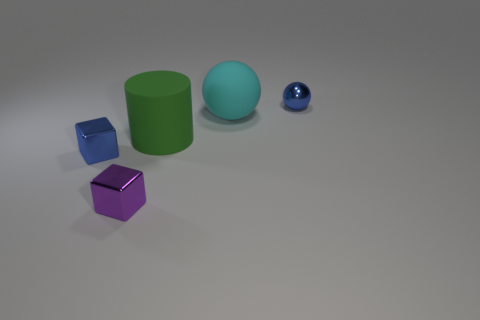There is a small ball; is it the same color as the small object that is on the left side of the purple object?
Offer a terse response. Yes. How many blocks are the same color as the small sphere?
Keep it short and to the point. 1. What number of objects are big green spheres or blue things?
Keep it short and to the point. 2. Does the ball in front of the tiny blue shiny sphere have the same size as the blue thing that is in front of the green cylinder?
Your response must be concise. No. What number of other objects are there of the same material as the tiny ball?
Your answer should be very brief. 2. Are there more small blue shiny things that are right of the large sphere than green objects behind the blue ball?
Your answer should be compact. Yes. There is a block that is behind the purple shiny object; what material is it?
Offer a terse response. Metal. Are there any other things that are the same color as the small sphere?
Ensure brevity in your answer.  Yes. The other object that is the same shape as the cyan rubber thing is what color?
Your answer should be very brief. Blue. Is the number of small objects on the left side of the tiny blue metal ball greater than the number of cyan spheres?
Make the answer very short. Yes. 